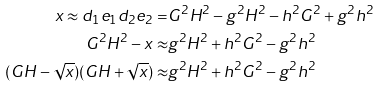<formula> <loc_0><loc_0><loc_500><loc_500>x \approx d _ { 1 } e _ { 1 } d _ { 2 } e _ { 2 } = & G ^ { 2 } H ^ { 2 } - g ^ { 2 } H ^ { 2 } - h ^ { 2 } G ^ { 2 } + g ^ { 2 } h ^ { 2 } \\ G ^ { 2 } H ^ { 2 } - x \approx & g ^ { 2 } H ^ { 2 } + h ^ { 2 } G ^ { 2 } - g ^ { 2 } h ^ { 2 } \\ ( G H - \sqrt { x } ) ( G H + \sqrt { x } ) \approx & g ^ { 2 } H ^ { 2 } + h ^ { 2 } G ^ { 2 } - g ^ { 2 } h ^ { 2 }</formula> 